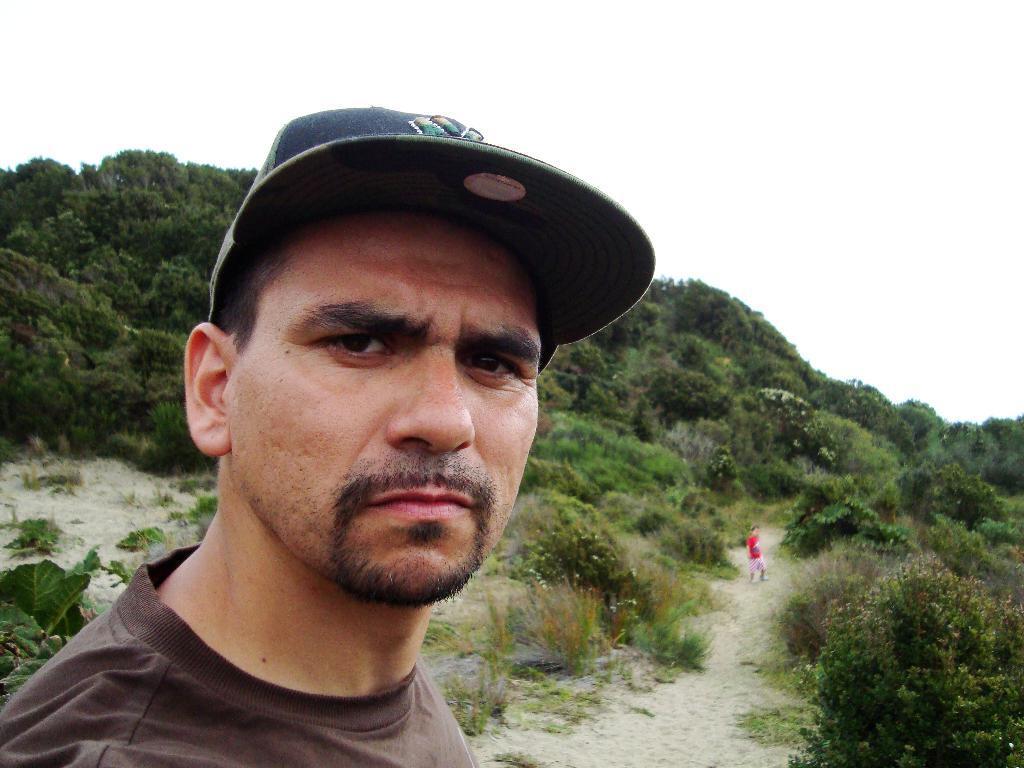How would you summarize this image in a sentence or two? In this picture there is a person wearing cap is in the left corner and there is a kid standing at some distance beside him and there are few plants and trees on either sides of them. 